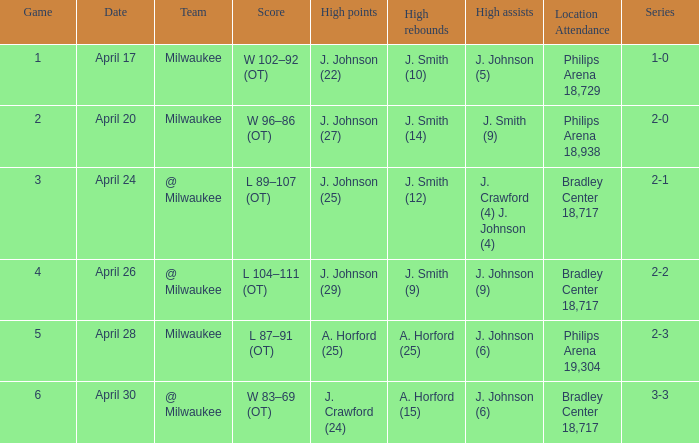What was the score in game 6? W 83–69 (OT). 